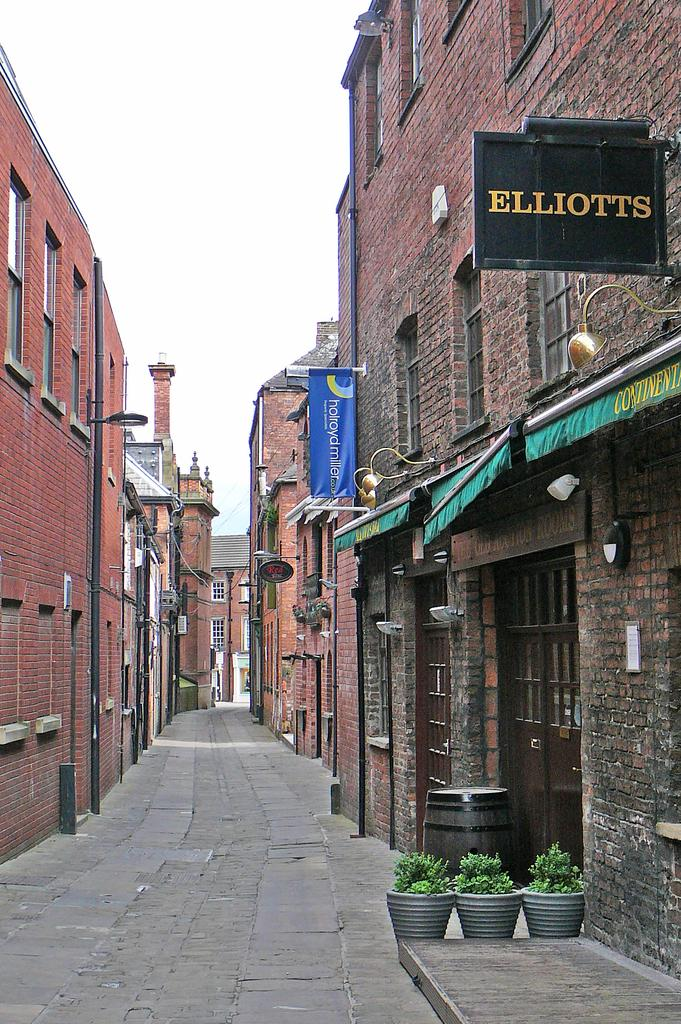What type of pathway is visible in the image? There is a road in the image. What kind of structures can be seen along the road? There are buildings with brick walls in the image. Are there any decorative elements in the image? Yes, there are flower pots in the image. What can be seen above the road and buildings? The sky is visible in the image. What might provide illumination in the image? Lights are present in the image. How does the railway move through the image? There is no railway present in the image. What causes the lights to burst in the image? There is no indication of lights bursting in the image. 